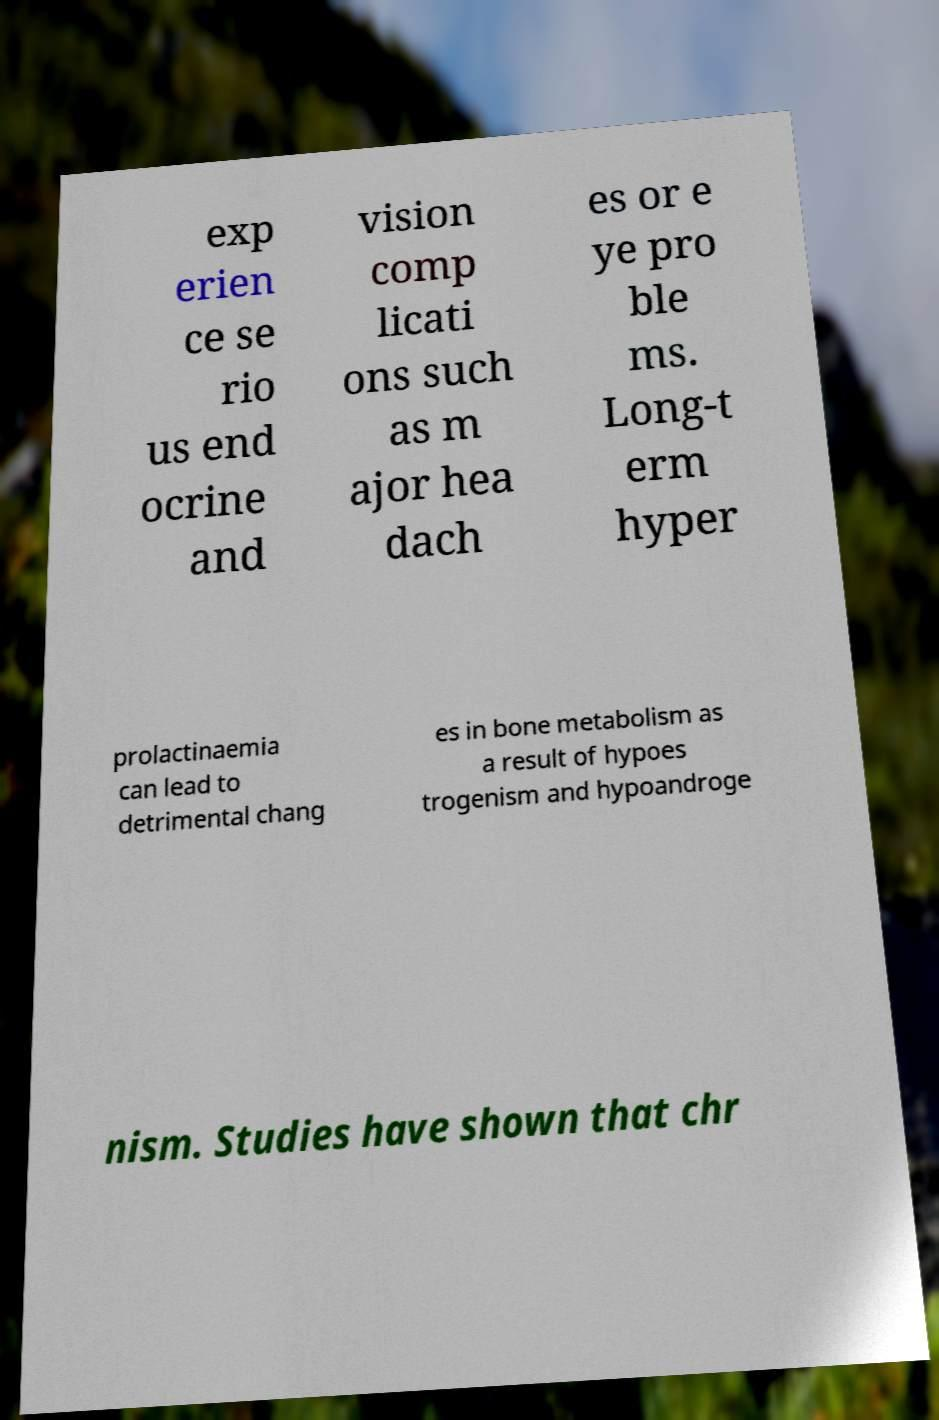There's text embedded in this image that I need extracted. Can you transcribe it verbatim? exp erien ce se rio us end ocrine and vision comp licati ons such as m ajor hea dach es or e ye pro ble ms. Long-t erm hyper prolactinaemia can lead to detrimental chang es in bone metabolism as a result of hypoes trogenism and hypoandroge nism. Studies have shown that chr 